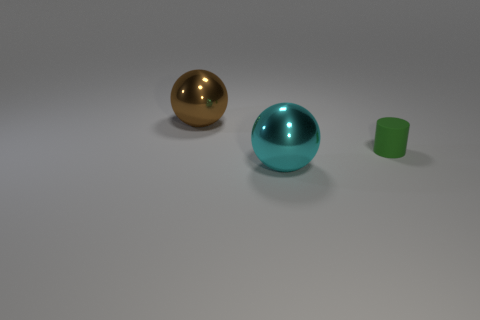Does the big metal object behind the small green rubber cylinder have the same shape as the large object that is in front of the big brown ball?
Provide a short and direct response. Yes. There is a thing that is the same size as the brown sphere; what is its shape?
Offer a very short reply. Sphere. What number of rubber objects are gray cylinders or green objects?
Ensure brevity in your answer.  1. Is the material of the large sphere that is on the right side of the large brown shiny thing the same as the tiny object to the right of the brown ball?
Ensure brevity in your answer.  No. What is the color of the other big sphere that is the same material as the big brown ball?
Provide a short and direct response. Cyan. Is the number of tiny rubber things that are to the right of the tiny green object greater than the number of things left of the brown sphere?
Provide a short and direct response. No. Are any brown balls visible?
Your answer should be compact. Yes. How many things are either large gray matte blocks or large cyan metallic objects?
Provide a succinct answer. 1. Is there another cylinder of the same color as the tiny matte cylinder?
Make the answer very short. No. What number of large things are to the left of the large object in front of the tiny green thing?
Make the answer very short. 1. 